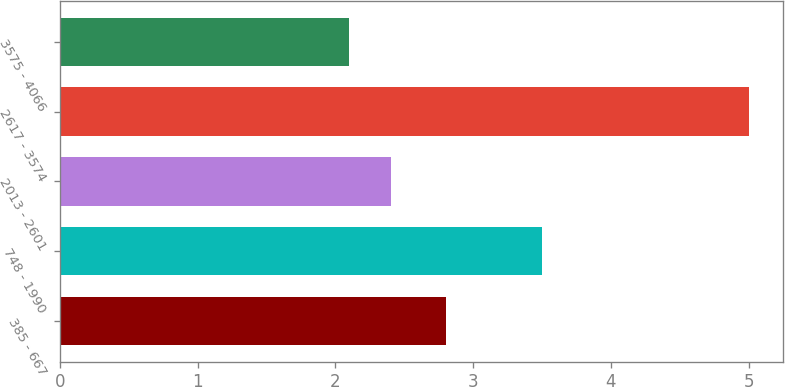<chart> <loc_0><loc_0><loc_500><loc_500><bar_chart><fcel>385 - 667<fcel>748 - 1990<fcel>2013 - 2601<fcel>2617 - 3574<fcel>3575 - 4066<nl><fcel>2.8<fcel>3.5<fcel>2.4<fcel>5<fcel>2.1<nl></chart> 